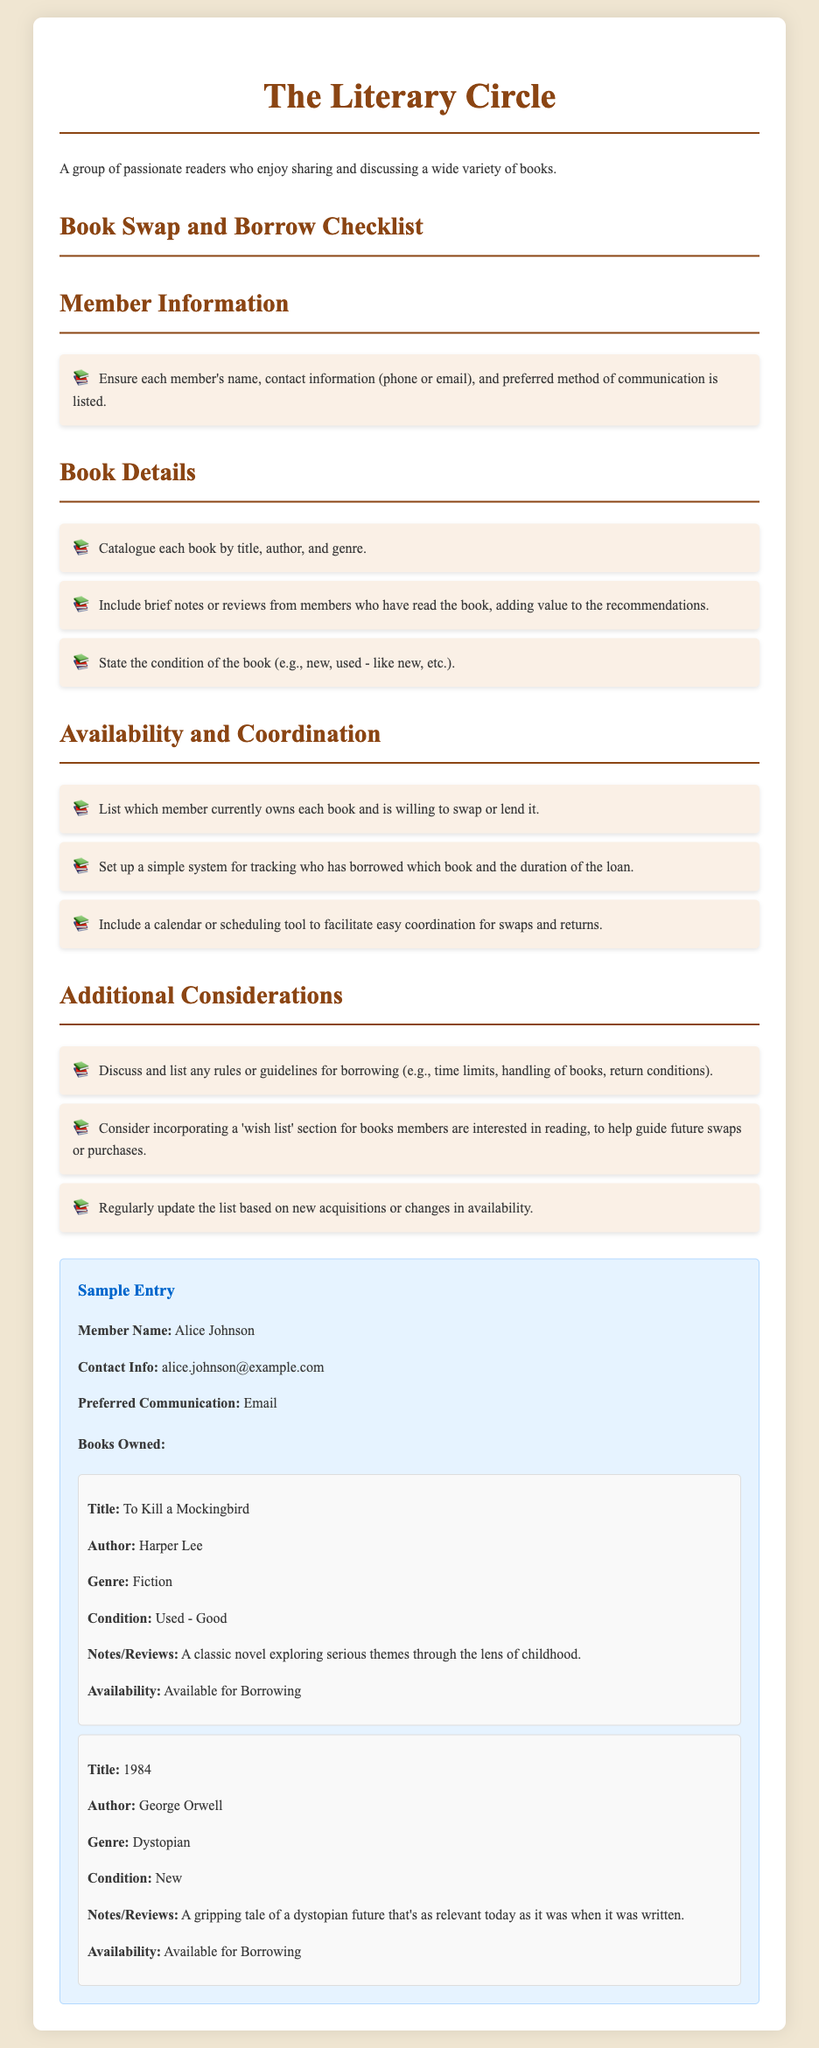what is the title of the checklist? The title of the checklist indicates the main subject of the document, which is "Book Swap and Borrow Checklist."
Answer: Book Swap and Borrow Checklist who is the member listed in the sample entry? The sample entry provides specific details about one member, which helps illustrate the format's intended use.
Answer: Alice Johnson what is the preferred communication method for Alice Johnson? This detail is pertinent for coordinating book swaps and lends communication effectively, as seen in the sample.
Answer: Email how many books are owned by Alice Johnson in the sample entry? The sample entry specifically showcases the books Alice Johnson owns, allowing members to see their availability.
Answer: 2 what genre is the book "1984"? The genre classification provides insight into the literary category of the book, which aids in member interests.
Answer: Dystopian what is a guideline suggested for borrowing books? Guidelines or rules help manage the borrowing process, ensuring clarity and fairness among members.
Answer: Time limits what type of information should be included about each book? Including specific information enhances the usability of the list and helps members make informed decisions regarding borrowing.
Answer: Title, author, and genre how often should the book list be updated? Regular updates ensure that the list reflects the current available books, enhancing the system's effectiveness.
Answer: Regularly 